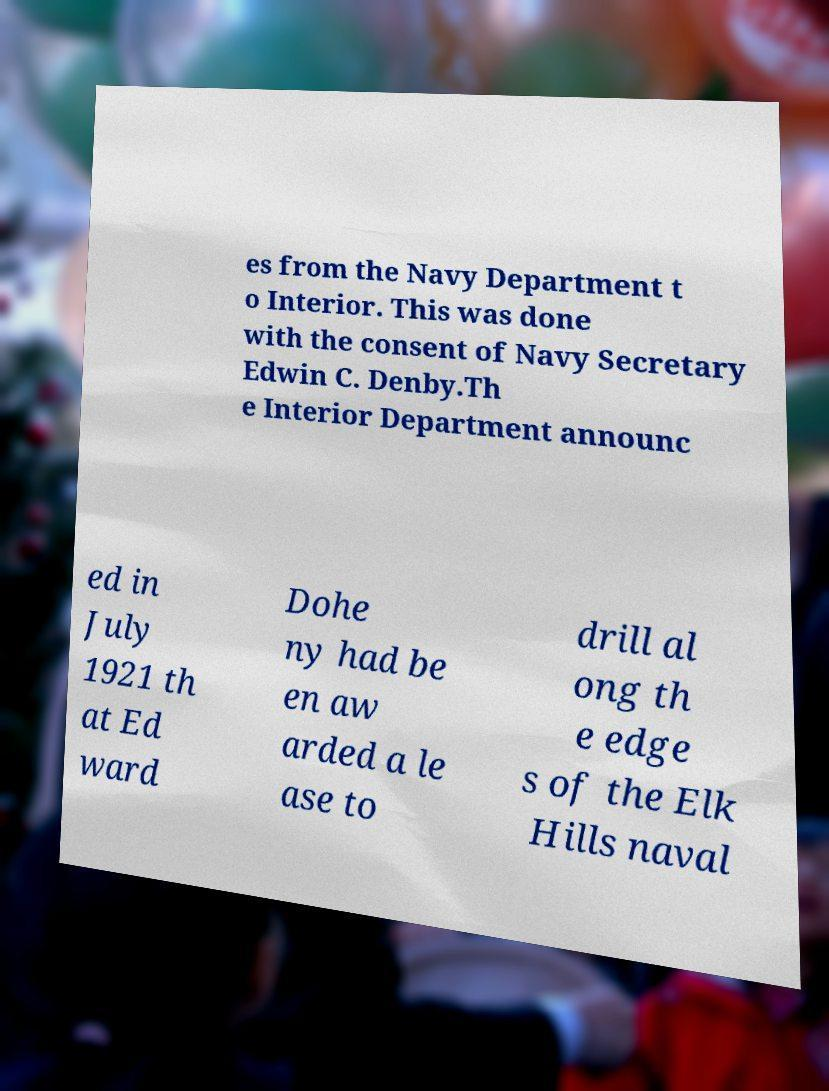Can you read and provide the text displayed in the image?This photo seems to have some interesting text. Can you extract and type it out for me? es from the Navy Department t o Interior. This was done with the consent of Navy Secretary Edwin C. Denby.Th e Interior Department announc ed in July 1921 th at Ed ward Dohe ny had be en aw arded a le ase to drill al ong th e edge s of the Elk Hills naval 